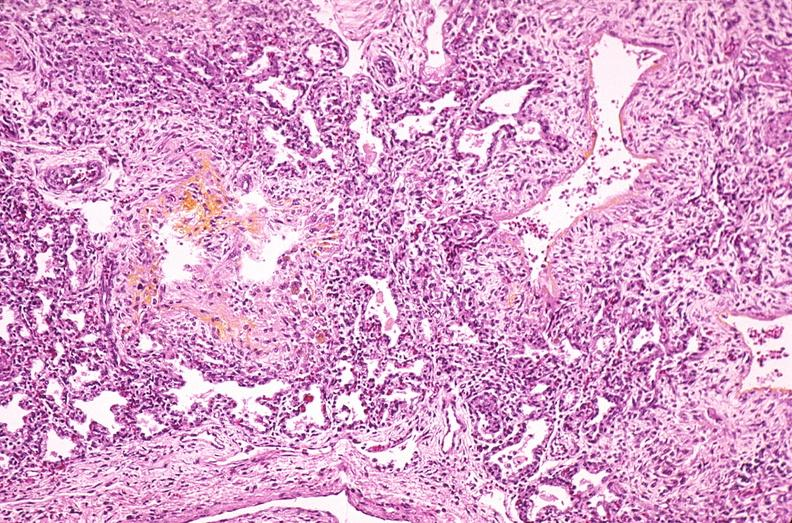does erythrophagocytosis new born show lung, hyaline membrane disease, yellow discoloration due to hyperbilirubinemia?
Answer the question using a single word or phrase. No 